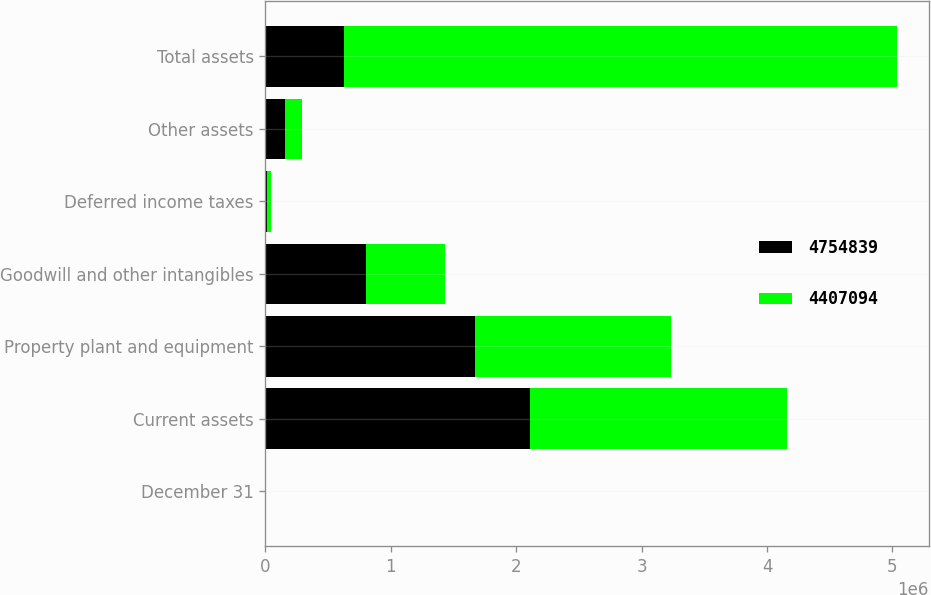<chart> <loc_0><loc_0><loc_500><loc_500><stacked_bar_chart><ecel><fcel>December 31<fcel>Current assets<fcel>Property plant and equipment<fcel>Goodwill and other intangibles<fcel>Deferred income taxes<fcel>Other assets<fcel>Total assets<nl><fcel>4.75484e+06<fcel>2012<fcel>2.11348e+06<fcel>1.67407e+06<fcel>802716<fcel>12448<fcel>152119<fcel>628658<nl><fcel>4.40709e+06<fcel>2011<fcel>2.04656e+06<fcel>1.55972e+06<fcel>628658<fcel>33439<fcel>138722<fcel>4.40709e+06<nl></chart> 